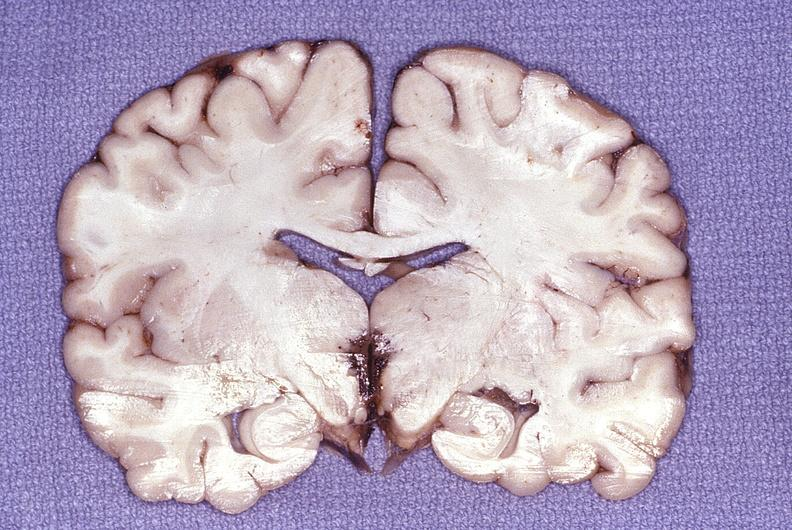does stein leventhal show wernicke 's encephalopathy?
Answer the question using a single word or phrase. No 